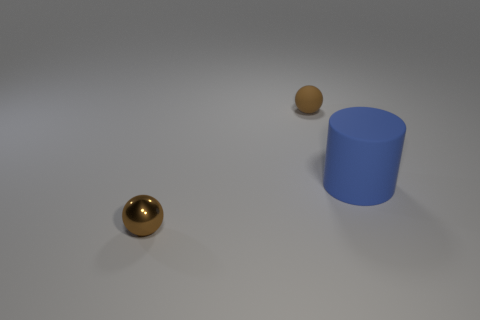How many small brown spheres have the same material as the cylinder?
Keep it short and to the point. 1. What is the shape of the shiny thing that is the same color as the tiny rubber ball?
Provide a short and direct response. Sphere. Are there the same number of things on the left side of the small rubber object and brown spheres?
Give a very brief answer. No. There is a brown ball that is in front of the brown rubber object; how big is it?
Offer a very short reply. Small. How many large things are brown metallic spheres or matte spheres?
Give a very brief answer. 0. There is a metal thing that is the same shape as the tiny rubber object; what color is it?
Offer a very short reply. Brown. Is the size of the blue matte cylinder the same as the brown shiny sphere?
Provide a succinct answer. No. What number of objects are yellow metal objects or small brown shiny balls that are in front of the large blue rubber cylinder?
Give a very brief answer. 1. There is a tiny ball on the left side of the tiny matte ball that is behind the blue thing; what is its color?
Give a very brief answer. Brown. Does the rubber object that is to the left of the blue thing have the same color as the small metal ball?
Offer a terse response. Yes. 